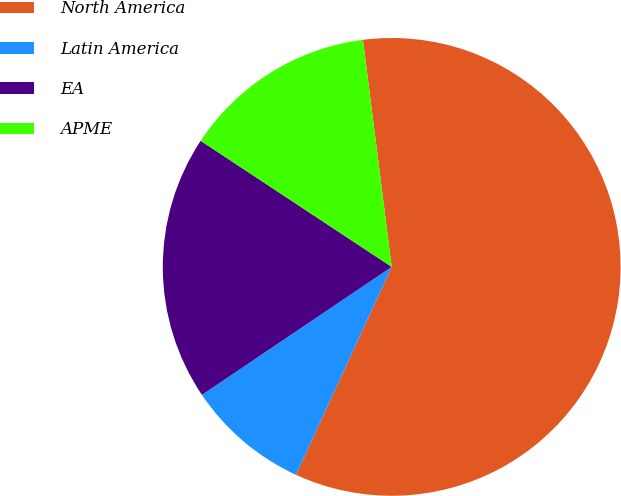<chart> <loc_0><loc_0><loc_500><loc_500><pie_chart><fcel>North America<fcel>Latin America<fcel>EA<fcel>APME<nl><fcel>58.88%<fcel>8.69%<fcel>18.73%<fcel>13.71%<nl></chart> 